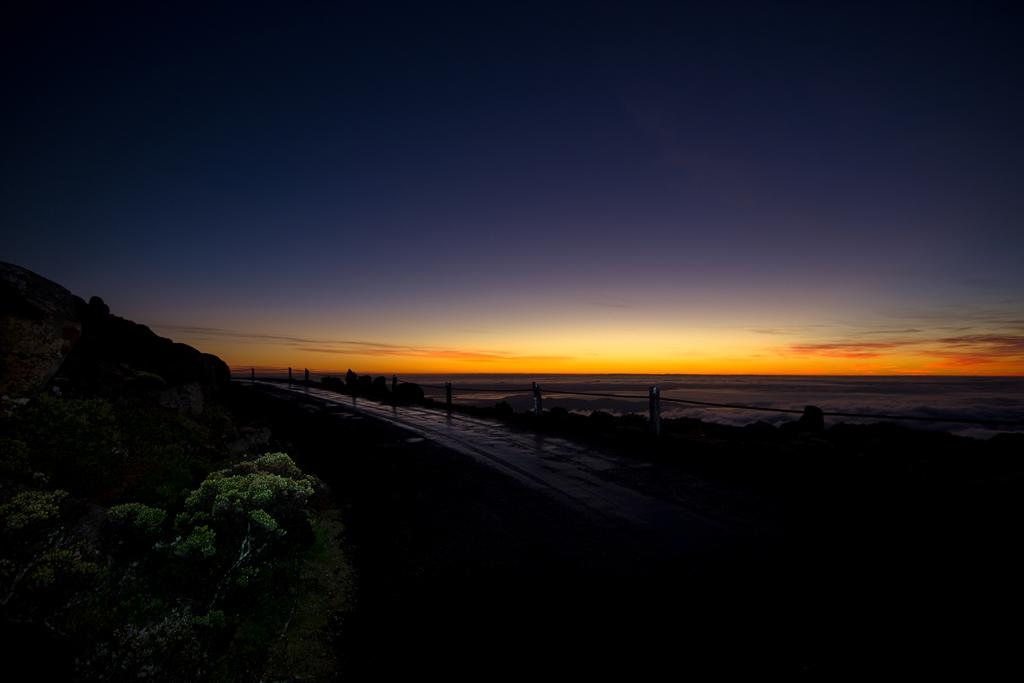What type of vegetation is on the left side of the image? There are trees and plants on the left side of the image. What can be seen in the middle of the image? There is a road in the middle of the image. What natural feature is on the left side of the image? There is a river on the left side of the image. What is visible in the background of the image? The sky is visible in the background of the image. What type of apples can be seen growing on the trees in the image? There are no apples visible in the image; only trees and plants are present. Can you hear the bird singing in the image? There is no bird present in the image, so it is not possible to hear it singing. 